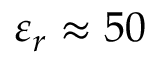Convert formula to latex. <formula><loc_0><loc_0><loc_500><loc_500>\varepsilon _ { r } \approx 5 0</formula> 